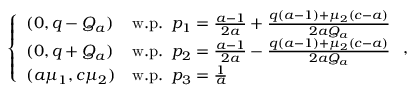<formula> <loc_0><loc_0><loc_500><loc_500>\left \{ \begin{array} { l l } { ( 0 , q - Q _ { a } ) } & { w . p . \, p _ { 1 } = \frac { a - 1 } { 2 a } + \frac { q ( a - 1 ) + \mu _ { 2 } ( c - a ) } { 2 a Q _ { a } } } \\ { ( 0 , q + Q _ { a } ) } & { w . p . \, p _ { 2 } = \frac { a - 1 } { 2 a } - \frac { q ( a - 1 ) + \mu _ { 2 } ( c - a ) } { 2 a Q _ { a } } } \\ { ( a \mu _ { 1 } , c \mu _ { 2 } ) } & { w . p . \, p _ { 3 } = \frac { 1 } { a } } \end{array} ,</formula> 